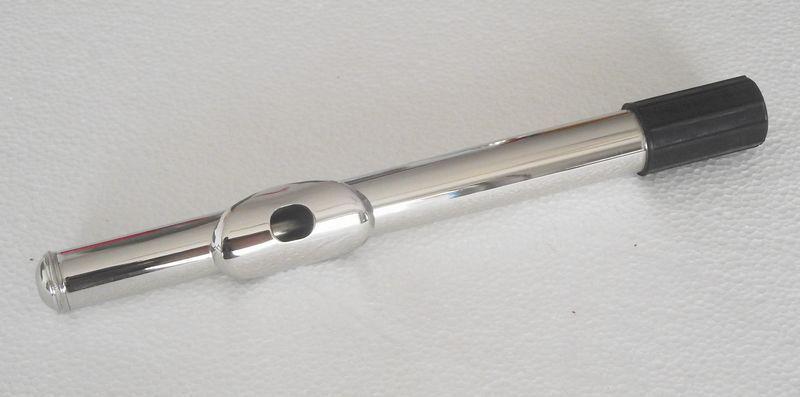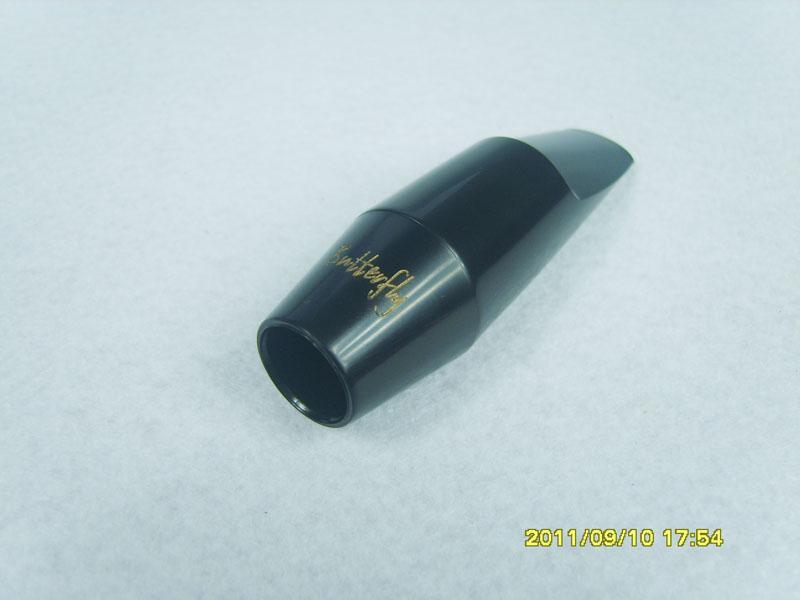The first image is the image on the left, the second image is the image on the right. Assess this claim about the two images: "In the right image, the instrument mouthpiece is gold colored on a silver body.". Correct or not? Answer yes or no. No. The first image is the image on the left, the second image is the image on the right. Examine the images to the left and right. Is the description "The right image shows a silver tube angled upward to the right, with a gold oblong shape with a hole in it near the middle of the tube." accurate? Answer yes or no. No. 